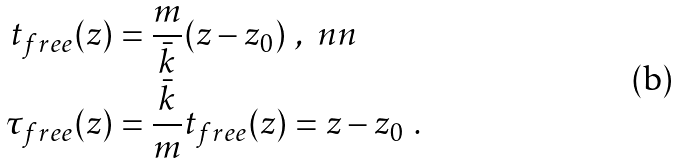Convert formula to latex. <formula><loc_0><loc_0><loc_500><loc_500>t _ { f r e e } ( z ) & = \frac { m } { \bar { k } } ( z - z _ { 0 } ) \ , \ n n \\ \tau _ { f r e e } ( z ) & = \frac { \bar { k } } { m } t _ { f r e e } ( z ) = z - z _ { 0 } \ .</formula> 